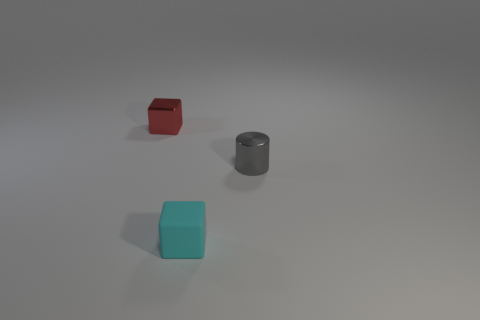What color is the metallic thing that is in front of the small metallic thing that is to the left of the cube in front of the metal cube?
Offer a terse response. Gray. There is a thing that is in front of the red cube and behind the cyan matte object; how big is it?
Make the answer very short. Small. How many other things are there of the same shape as the tiny cyan matte thing?
Your response must be concise. 1. How many cylinders are shiny things or tiny rubber objects?
Give a very brief answer. 1. There is a tiny block that is right of the cube on the left side of the small cyan matte cube; is there a cube to the left of it?
Offer a very short reply. Yes. The other thing that is the same shape as the rubber object is what color?
Offer a very short reply. Red. How many green objects are either blocks or small matte cubes?
Give a very brief answer. 0. The red block to the left of the tiny cube that is in front of the metal cylinder is made of what material?
Make the answer very short. Metal. Does the cyan object have the same shape as the small red object?
Ensure brevity in your answer.  Yes. What color is the matte object that is the same size as the gray metallic object?
Your response must be concise. Cyan. 